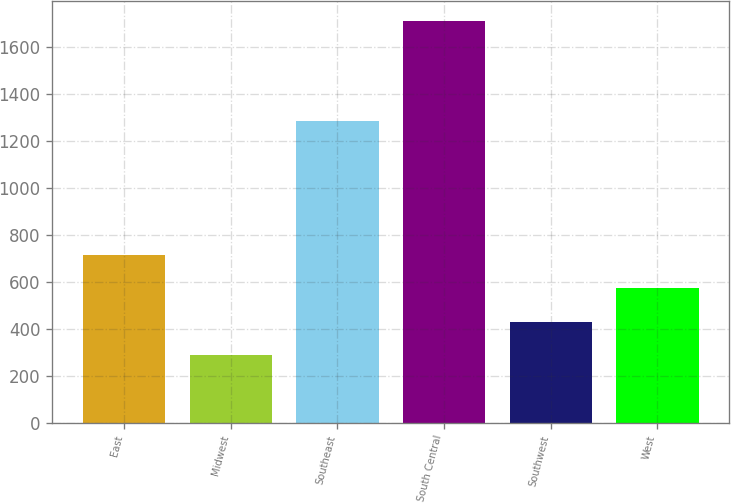Convert chart to OTSL. <chart><loc_0><loc_0><loc_500><loc_500><bar_chart><fcel>East<fcel>Midwest<fcel>Southeast<fcel>South Central<fcel>Southwest<fcel>West<nl><fcel>714.6<fcel>288<fcel>1285<fcel>1710<fcel>430.2<fcel>572.4<nl></chart> 